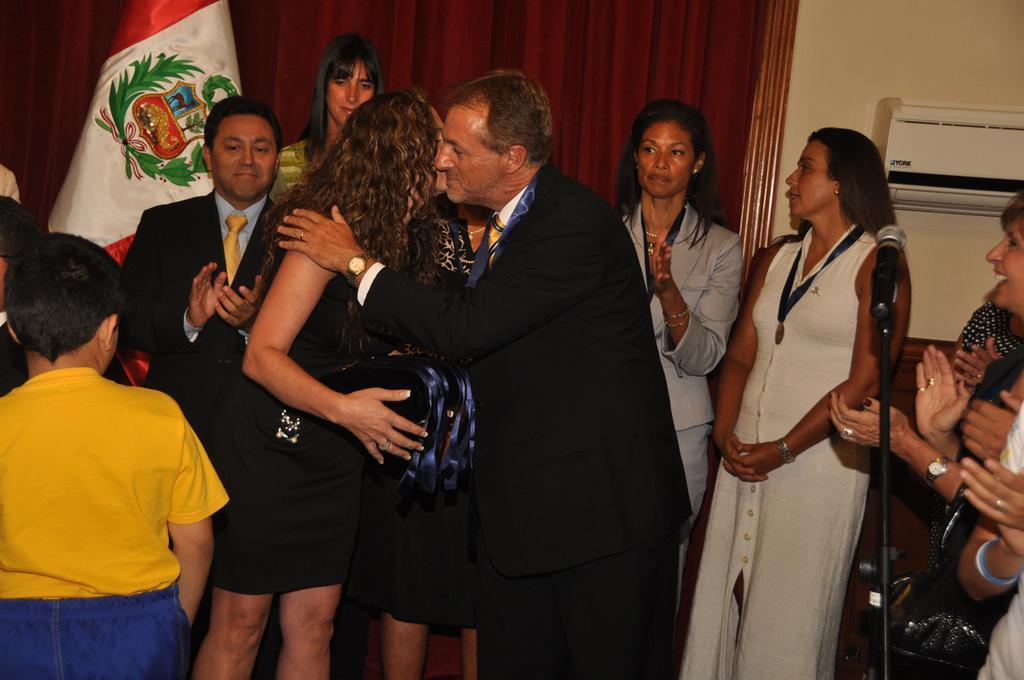Please provide a concise description of this image. This image is taken indoors. In the background there is a wall with an air conditioner. On the left side of the image there is a flag and a few people are standing on the floor. On the right side of the image a few people are standing on the floor and clapping their hands and there is a mic. In the middle of the image there are a few people standing on the ground. 